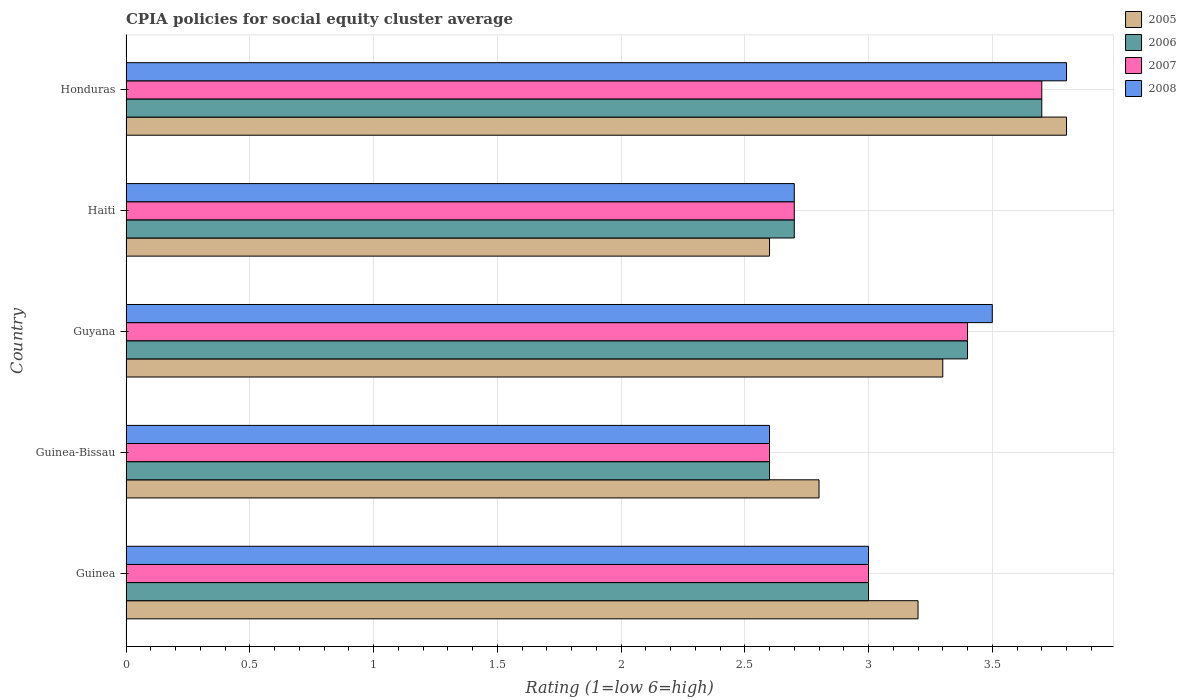Are the number of bars on each tick of the Y-axis equal?
Provide a short and direct response. Yes. What is the label of the 5th group of bars from the top?
Offer a terse response. Guinea. Across all countries, what is the minimum CPIA rating in 2005?
Make the answer very short. 2.6. In which country was the CPIA rating in 2007 maximum?
Offer a terse response. Honduras. In which country was the CPIA rating in 2007 minimum?
Provide a succinct answer. Guinea-Bissau. What is the total CPIA rating in 2008 in the graph?
Ensure brevity in your answer.  15.6. What is the difference between the CPIA rating in 2005 in Guinea and that in Haiti?
Your answer should be compact. 0.6. What is the difference between the CPIA rating in 2007 in Guinea and the CPIA rating in 2008 in Guinea-Bissau?
Offer a very short reply. 0.4. What is the average CPIA rating in 2008 per country?
Give a very brief answer. 3.12. What is the difference between the CPIA rating in 2005 and CPIA rating in 2006 in Haiti?
Make the answer very short. -0.1. In how many countries, is the CPIA rating in 2006 greater than 3.6 ?
Offer a very short reply. 1. What is the ratio of the CPIA rating in 2007 in Guyana to that in Haiti?
Offer a terse response. 1.26. What is the difference between the highest and the second highest CPIA rating in 2006?
Your answer should be compact. 0.3. What is the difference between the highest and the lowest CPIA rating in 2005?
Provide a short and direct response. 1.2. In how many countries, is the CPIA rating in 2008 greater than the average CPIA rating in 2008 taken over all countries?
Give a very brief answer. 2. Is the sum of the CPIA rating in 2008 in Guyana and Honduras greater than the maximum CPIA rating in 2005 across all countries?
Your answer should be compact. Yes. What does the 3rd bar from the bottom in Guinea represents?
Ensure brevity in your answer.  2007. How many countries are there in the graph?
Make the answer very short. 5. What is the difference between two consecutive major ticks on the X-axis?
Your answer should be very brief. 0.5. Does the graph contain grids?
Your response must be concise. Yes. How are the legend labels stacked?
Offer a terse response. Vertical. What is the title of the graph?
Your answer should be very brief. CPIA policies for social equity cluster average. What is the label or title of the Y-axis?
Provide a short and direct response. Country. What is the Rating (1=low 6=high) in 2005 in Guinea?
Keep it short and to the point. 3.2. What is the Rating (1=low 6=high) in 2007 in Guinea?
Offer a terse response. 3. What is the Rating (1=low 6=high) of 2006 in Guinea-Bissau?
Offer a very short reply. 2.6. What is the Rating (1=low 6=high) in 2005 in Guyana?
Your answer should be very brief. 3.3. What is the Rating (1=low 6=high) in 2006 in Guyana?
Your answer should be very brief. 3.4. What is the Rating (1=low 6=high) in 2007 in Guyana?
Make the answer very short. 3.4. What is the Rating (1=low 6=high) in 2008 in Guyana?
Give a very brief answer. 3.5. What is the Rating (1=low 6=high) in 2005 in Haiti?
Keep it short and to the point. 2.6. What is the Rating (1=low 6=high) in 2005 in Honduras?
Provide a succinct answer. 3.8. What is the Rating (1=low 6=high) in 2008 in Honduras?
Offer a very short reply. 3.8. Across all countries, what is the maximum Rating (1=low 6=high) of 2007?
Provide a succinct answer. 3.7. Across all countries, what is the maximum Rating (1=low 6=high) of 2008?
Offer a very short reply. 3.8. Across all countries, what is the minimum Rating (1=low 6=high) of 2005?
Provide a succinct answer. 2.6. What is the total Rating (1=low 6=high) of 2007 in the graph?
Make the answer very short. 15.4. What is the difference between the Rating (1=low 6=high) of 2005 in Guinea and that in Guinea-Bissau?
Ensure brevity in your answer.  0.4. What is the difference between the Rating (1=low 6=high) in 2007 in Guinea and that in Guinea-Bissau?
Your response must be concise. 0.4. What is the difference between the Rating (1=low 6=high) in 2008 in Guinea and that in Guinea-Bissau?
Your response must be concise. 0.4. What is the difference between the Rating (1=low 6=high) of 2005 in Guinea and that in Guyana?
Your answer should be very brief. -0.1. What is the difference between the Rating (1=low 6=high) in 2005 in Guinea and that in Haiti?
Make the answer very short. 0.6. What is the difference between the Rating (1=low 6=high) in 2006 in Guinea and that in Haiti?
Make the answer very short. 0.3. What is the difference between the Rating (1=low 6=high) in 2005 in Guinea and that in Honduras?
Your answer should be compact. -0.6. What is the difference between the Rating (1=low 6=high) of 2006 in Guinea and that in Honduras?
Give a very brief answer. -0.7. What is the difference between the Rating (1=low 6=high) of 2008 in Guinea and that in Honduras?
Keep it short and to the point. -0.8. What is the difference between the Rating (1=low 6=high) in 2008 in Guinea-Bissau and that in Guyana?
Give a very brief answer. -0.9. What is the difference between the Rating (1=low 6=high) in 2007 in Guinea-Bissau and that in Haiti?
Give a very brief answer. -0.1. What is the difference between the Rating (1=low 6=high) in 2005 in Guinea-Bissau and that in Honduras?
Make the answer very short. -1. What is the difference between the Rating (1=low 6=high) in 2007 in Guinea-Bissau and that in Honduras?
Your answer should be very brief. -1.1. What is the difference between the Rating (1=low 6=high) in 2006 in Guyana and that in Haiti?
Make the answer very short. 0.7. What is the difference between the Rating (1=low 6=high) of 2007 in Guyana and that in Haiti?
Ensure brevity in your answer.  0.7. What is the difference between the Rating (1=low 6=high) of 2008 in Guyana and that in Haiti?
Provide a succinct answer. 0.8. What is the difference between the Rating (1=low 6=high) of 2005 in Guyana and that in Honduras?
Provide a short and direct response. -0.5. What is the difference between the Rating (1=low 6=high) in 2006 in Guyana and that in Honduras?
Provide a short and direct response. -0.3. What is the difference between the Rating (1=low 6=high) in 2007 in Guyana and that in Honduras?
Your response must be concise. -0.3. What is the difference between the Rating (1=low 6=high) in 2008 in Guyana and that in Honduras?
Provide a short and direct response. -0.3. What is the difference between the Rating (1=low 6=high) in 2005 in Haiti and that in Honduras?
Your answer should be very brief. -1.2. What is the difference between the Rating (1=low 6=high) of 2005 in Guinea and the Rating (1=low 6=high) of 2006 in Guinea-Bissau?
Your response must be concise. 0.6. What is the difference between the Rating (1=low 6=high) of 2005 in Guinea and the Rating (1=low 6=high) of 2007 in Guinea-Bissau?
Keep it short and to the point. 0.6. What is the difference between the Rating (1=low 6=high) of 2005 in Guinea and the Rating (1=low 6=high) of 2008 in Guinea-Bissau?
Give a very brief answer. 0.6. What is the difference between the Rating (1=low 6=high) in 2006 in Guinea and the Rating (1=low 6=high) in 2007 in Guinea-Bissau?
Offer a very short reply. 0.4. What is the difference between the Rating (1=low 6=high) of 2006 in Guinea and the Rating (1=low 6=high) of 2008 in Guinea-Bissau?
Keep it short and to the point. 0.4. What is the difference between the Rating (1=low 6=high) of 2005 in Guinea and the Rating (1=low 6=high) of 2006 in Guyana?
Ensure brevity in your answer.  -0.2. What is the difference between the Rating (1=low 6=high) of 2005 in Guinea and the Rating (1=low 6=high) of 2008 in Guyana?
Ensure brevity in your answer.  -0.3. What is the difference between the Rating (1=low 6=high) of 2006 in Guinea and the Rating (1=low 6=high) of 2007 in Guyana?
Offer a terse response. -0.4. What is the difference between the Rating (1=low 6=high) in 2006 in Guinea and the Rating (1=low 6=high) in 2008 in Guyana?
Your response must be concise. -0.5. What is the difference between the Rating (1=low 6=high) of 2007 in Guinea and the Rating (1=low 6=high) of 2008 in Guyana?
Ensure brevity in your answer.  -0.5. What is the difference between the Rating (1=low 6=high) of 2005 in Guinea and the Rating (1=low 6=high) of 2006 in Haiti?
Provide a short and direct response. 0.5. What is the difference between the Rating (1=low 6=high) in 2005 in Guinea and the Rating (1=low 6=high) in 2007 in Haiti?
Make the answer very short. 0.5. What is the difference between the Rating (1=low 6=high) in 2005 in Guinea and the Rating (1=low 6=high) in 2008 in Haiti?
Provide a succinct answer. 0.5. What is the difference between the Rating (1=low 6=high) of 2006 in Guinea and the Rating (1=low 6=high) of 2008 in Haiti?
Keep it short and to the point. 0.3. What is the difference between the Rating (1=low 6=high) of 2005 in Guinea and the Rating (1=low 6=high) of 2006 in Honduras?
Provide a short and direct response. -0.5. What is the difference between the Rating (1=low 6=high) of 2005 in Guinea and the Rating (1=low 6=high) of 2007 in Honduras?
Your response must be concise. -0.5. What is the difference between the Rating (1=low 6=high) of 2005 in Guinea and the Rating (1=low 6=high) of 2008 in Honduras?
Your response must be concise. -0.6. What is the difference between the Rating (1=low 6=high) of 2006 in Guinea and the Rating (1=low 6=high) of 2007 in Honduras?
Your answer should be very brief. -0.7. What is the difference between the Rating (1=low 6=high) of 2006 in Guinea and the Rating (1=low 6=high) of 2008 in Honduras?
Keep it short and to the point. -0.8. What is the difference between the Rating (1=low 6=high) in 2007 in Guinea and the Rating (1=low 6=high) in 2008 in Honduras?
Offer a terse response. -0.8. What is the difference between the Rating (1=low 6=high) of 2005 in Guinea-Bissau and the Rating (1=low 6=high) of 2006 in Guyana?
Offer a very short reply. -0.6. What is the difference between the Rating (1=low 6=high) of 2005 in Guinea-Bissau and the Rating (1=low 6=high) of 2007 in Guyana?
Your response must be concise. -0.6. What is the difference between the Rating (1=low 6=high) of 2006 in Guinea-Bissau and the Rating (1=low 6=high) of 2007 in Guyana?
Provide a short and direct response. -0.8. What is the difference between the Rating (1=low 6=high) in 2006 in Guinea-Bissau and the Rating (1=low 6=high) in 2008 in Guyana?
Your answer should be compact. -0.9. What is the difference between the Rating (1=low 6=high) in 2007 in Guinea-Bissau and the Rating (1=low 6=high) in 2008 in Guyana?
Your answer should be compact. -0.9. What is the difference between the Rating (1=low 6=high) in 2005 in Guinea-Bissau and the Rating (1=low 6=high) in 2006 in Haiti?
Give a very brief answer. 0.1. What is the difference between the Rating (1=low 6=high) of 2005 in Guinea-Bissau and the Rating (1=low 6=high) of 2008 in Haiti?
Keep it short and to the point. 0.1. What is the difference between the Rating (1=low 6=high) of 2006 in Guinea-Bissau and the Rating (1=low 6=high) of 2007 in Haiti?
Provide a succinct answer. -0.1. What is the difference between the Rating (1=low 6=high) in 2006 in Guinea-Bissau and the Rating (1=low 6=high) in 2008 in Haiti?
Your response must be concise. -0.1. What is the difference between the Rating (1=low 6=high) of 2007 in Guinea-Bissau and the Rating (1=low 6=high) of 2008 in Haiti?
Offer a terse response. -0.1. What is the difference between the Rating (1=low 6=high) in 2005 in Guinea-Bissau and the Rating (1=low 6=high) in 2006 in Honduras?
Provide a succinct answer. -0.9. What is the difference between the Rating (1=low 6=high) in 2005 in Guinea-Bissau and the Rating (1=low 6=high) in 2007 in Honduras?
Offer a very short reply. -0.9. What is the difference between the Rating (1=low 6=high) in 2006 in Guinea-Bissau and the Rating (1=low 6=high) in 2008 in Honduras?
Provide a short and direct response. -1.2. What is the difference between the Rating (1=low 6=high) in 2007 in Guinea-Bissau and the Rating (1=low 6=high) in 2008 in Honduras?
Make the answer very short. -1.2. What is the difference between the Rating (1=low 6=high) of 2005 in Guyana and the Rating (1=low 6=high) of 2007 in Haiti?
Provide a succinct answer. 0.6. What is the difference between the Rating (1=low 6=high) of 2006 in Guyana and the Rating (1=low 6=high) of 2007 in Haiti?
Provide a short and direct response. 0.7. What is the difference between the Rating (1=low 6=high) in 2006 in Guyana and the Rating (1=low 6=high) in 2008 in Haiti?
Provide a short and direct response. 0.7. What is the difference between the Rating (1=low 6=high) of 2007 in Guyana and the Rating (1=low 6=high) of 2008 in Haiti?
Give a very brief answer. 0.7. What is the difference between the Rating (1=low 6=high) of 2005 in Guyana and the Rating (1=low 6=high) of 2006 in Honduras?
Your response must be concise. -0.4. What is the difference between the Rating (1=low 6=high) in 2005 in Guyana and the Rating (1=low 6=high) in 2007 in Honduras?
Your answer should be compact. -0.4. What is the difference between the Rating (1=low 6=high) of 2006 in Guyana and the Rating (1=low 6=high) of 2007 in Honduras?
Your answer should be compact. -0.3. What is the difference between the Rating (1=low 6=high) in 2006 in Guyana and the Rating (1=low 6=high) in 2008 in Honduras?
Your response must be concise. -0.4. What is the difference between the Rating (1=low 6=high) of 2005 in Haiti and the Rating (1=low 6=high) of 2006 in Honduras?
Provide a succinct answer. -1.1. What is the difference between the Rating (1=low 6=high) of 2005 in Haiti and the Rating (1=low 6=high) of 2007 in Honduras?
Give a very brief answer. -1.1. What is the difference between the Rating (1=low 6=high) in 2005 in Haiti and the Rating (1=low 6=high) in 2008 in Honduras?
Make the answer very short. -1.2. What is the difference between the Rating (1=low 6=high) of 2006 in Haiti and the Rating (1=low 6=high) of 2007 in Honduras?
Your response must be concise. -1. What is the average Rating (1=low 6=high) of 2005 per country?
Ensure brevity in your answer.  3.14. What is the average Rating (1=low 6=high) in 2006 per country?
Your answer should be compact. 3.08. What is the average Rating (1=low 6=high) in 2007 per country?
Ensure brevity in your answer.  3.08. What is the average Rating (1=low 6=high) of 2008 per country?
Your answer should be compact. 3.12. What is the difference between the Rating (1=low 6=high) of 2005 and Rating (1=low 6=high) of 2007 in Guinea?
Provide a short and direct response. 0.2. What is the difference between the Rating (1=low 6=high) in 2006 and Rating (1=low 6=high) in 2008 in Guinea?
Your answer should be very brief. 0. What is the difference between the Rating (1=low 6=high) in 2007 and Rating (1=low 6=high) in 2008 in Guinea?
Make the answer very short. 0. What is the difference between the Rating (1=low 6=high) of 2005 and Rating (1=low 6=high) of 2008 in Guinea-Bissau?
Offer a terse response. 0.2. What is the difference between the Rating (1=low 6=high) of 2006 and Rating (1=low 6=high) of 2007 in Guinea-Bissau?
Your answer should be very brief. 0. What is the difference between the Rating (1=low 6=high) of 2006 and Rating (1=low 6=high) of 2008 in Guinea-Bissau?
Your response must be concise. 0. What is the difference between the Rating (1=low 6=high) of 2007 and Rating (1=low 6=high) of 2008 in Guinea-Bissau?
Provide a succinct answer. 0. What is the difference between the Rating (1=low 6=high) in 2005 and Rating (1=low 6=high) in 2007 in Guyana?
Your answer should be very brief. -0.1. What is the difference between the Rating (1=low 6=high) of 2006 and Rating (1=low 6=high) of 2007 in Guyana?
Offer a very short reply. 0. What is the difference between the Rating (1=low 6=high) of 2006 and Rating (1=low 6=high) of 2008 in Guyana?
Ensure brevity in your answer.  -0.1. What is the difference between the Rating (1=low 6=high) in 2005 and Rating (1=low 6=high) in 2006 in Haiti?
Provide a short and direct response. -0.1. What is the difference between the Rating (1=low 6=high) of 2005 and Rating (1=low 6=high) of 2007 in Haiti?
Ensure brevity in your answer.  -0.1. What is the difference between the Rating (1=low 6=high) in 2006 and Rating (1=low 6=high) in 2008 in Haiti?
Offer a terse response. 0. What is the difference between the Rating (1=low 6=high) of 2005 and Rating (1=low 6=high) of 2007 in Honduras?
Make the answer very short. 0.1. What is the difference between the Rating (1=low 6=high) of 2007 and Rating (1=low 6=high) of 2008 in Honduras?
Give a very brief answer. -0.1. What is the ratio of the Rating (1=low 6=high) of 2005 in Guinea to that in Guinea-Bissau?
Make the answer very short. 1.14. What is the ratio of the Rating (1=low 6=high) of 2006 in Guinea to that in Guinea-Bissau?
Your response must be concise. 1.15. What is the ratio of the Rating (1=low 6=high) in 2007 in Guinea to that in Guinea-Bissau?
Offer a very short reply. 1.15. What is the ratio of the Rating (1=low 6=high) in 2008 in Guinea to that in Guinea-Bissau?
Provide a short and direct response. 1.15. What is the ratio of the Rating (1=low 6=high) in 2005 in Guinea to that in Guyana?
Make the answer very short. 0.97. What is the ratio of the Rating (1=low 6=high) of 2006 in Guinea to that in Guyana?
Your response must be concise. 0.88. What is the ratio of the Rating (1=low 6=high) in 2007 in Guinea to that in Guyana?
Offer a terse response. 0.88. What is the ratio of the Rating (1=low 6=high) of 2008 in Guinea to that in Guyana?
Your answer should be compact. 0.86. What is the ratio of the Rating (1=low 6=high) in 2005 in Guinea to that in Haiti?
Provide a succinct answer. 1.23. What is the ratio of the Rating (1=low 6=high) of 2005 in Guinea to that in Honduras?
Offer a terse response. 0.84. What is the ratio of the Rating (1=low 6=high) in 2006 in Guinea to that in Honduras?
Give a very brief answer. 0.81. What is the ratio of the Rating (1=low 6=high) in 2007 in Guinea to that in Honduras?
Provide a short and direct response. 0.81. What is the ratio of the Rating (1=low 6=high) in 2008 in Guinea to that in Honduras?
Ensure brevity in your answer.  0.79. What is the ratio of the Rating (1=low 6=high) in 2005 in Guinea-Bissau to that in Guyana?
Provide a short and direct response. 0.85. What is the ratio of the Rating (1=low 6=high) of 2006 in Guinea-Bissau to that in Guyana?
Keep it short and to the point. 0.76. What is the ratio of the Rating (1=low 6=high) in 2007 in Guinea-Bissau to that in Guyana?
Your answer should be very brief. 0.76. What is the ratio of the Rating (1=low 6=high) in 2008 in Guinea-Bissau to that in Guyana?
Offer a very short reply. 0.74. What is the ratio of the Rating (1=low 6=high) in 2005 in Guinea-Bissau to that in Haiti?
Your answer should be compact. 1.08. What is the ratio of the Rating (1=low 6=high) in 2006 in Guinea-Bissau to that in Haiti?
Ensure brevity in your answer.  0.96. What is the ratio of the Rating (1=low 6=high) of 2005 in Guinea-Bissau to that in Honduras?
Your response must be concise. 0.74. What is the ratio of the Rating (1=low 6=high) in 2006 in Guinea-Bissau to that in Honduras?
Keep it short and to the point. 0.7. What is the ratio of the Rating (1=low 6=high) in 2007 in Guinea-Bissau to that in Honduras?
Make the answer very short. 0.7. What is the ratio of the Rating (1=low 6=high) in 2008 in Guinea-Bissau to that in Honduras?
Your response must be concise. 0.68. What is the ratio of the Rating (1=low 6=high) in 2005 in Guyana to that in Haiti?
Your response must be concise. 1.27. What is the ratio of the Rating (1=low 6=high) of 2006 in Guyana to that in Haiti?
Give a very brief answer. 1.26. What is the ratio of the Rating (1=low 6=high) of 2007 in Guyana to that in Haiti?
Provide a succinct answer. 1.26. What is the ratio of the Rating (1=low 6=high) in 2008 in Guyana to that in Haiti?
Offer a very short reply. 1.3. What is the ratio of the Rating (1=low 6=high) in 2005 in Guyana to that in Honduras?
Ensure brevity in your answer.  0.87. What is the ratio of the Rating (1=low 6=high) in 2006 in Guyana to that in Honduras?
Offer a very short reply. 0.92. What is the ratio of the Rating (1=low 6=high) in 2007 in Guyana to that in Honduras?
Keep it short and to the point. 0.92. What is the ratio of the Rating (1=low 6=high) in 2008 in Guyana to that in Honduras?
Ensure brevity in your answer.  0.92. What is the ratio of the Rating (1=low 6=high) of 2005 in Haiti to that in Honduras?
Provide a short and direct response. 0.68. What is the ratio of the Rating (1=low 6=high) in 2006 in Haiti to that in Honduras?
Give a very brief answer. 0.73. What is the ratio of the Rating (1=low 6=high) of 2007 in Haiti to that in Honduras?
Your response must be concise. 0.73. What is the ratio of the Rating (1=low 6=high) in 2008 in Haiti to that in Honduras?
Make the answer very short. 0.71. What is the difference between the highest and the second highest Rating (1=low 6=high) of 2005?
Provide a short and direct response. 0.5. What is the difference between the highest and the second highest Rating (1=low 6=high) in 2006?
Make the answer very short. 0.3. What is the difference between the highest and the second highest Rating (1=low 6=high) of 2008?
Your response must be concise. 0.3. 